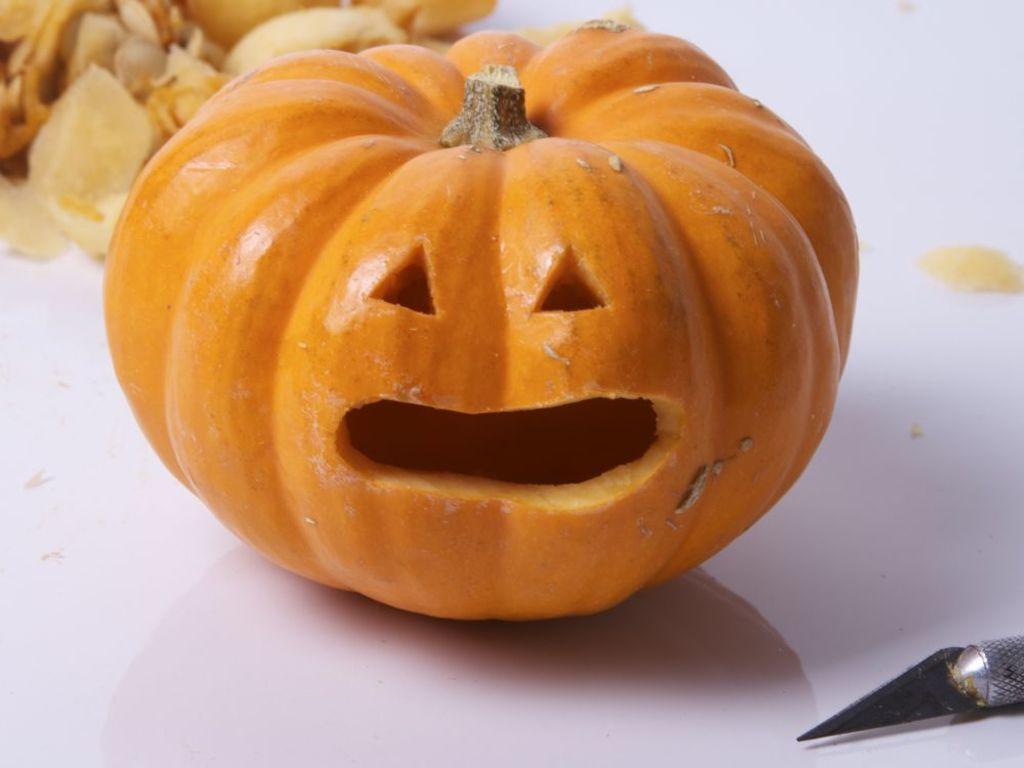Please provide a concise description of this image. In this image we can see pumpkin and pen knife placed on the surface. 